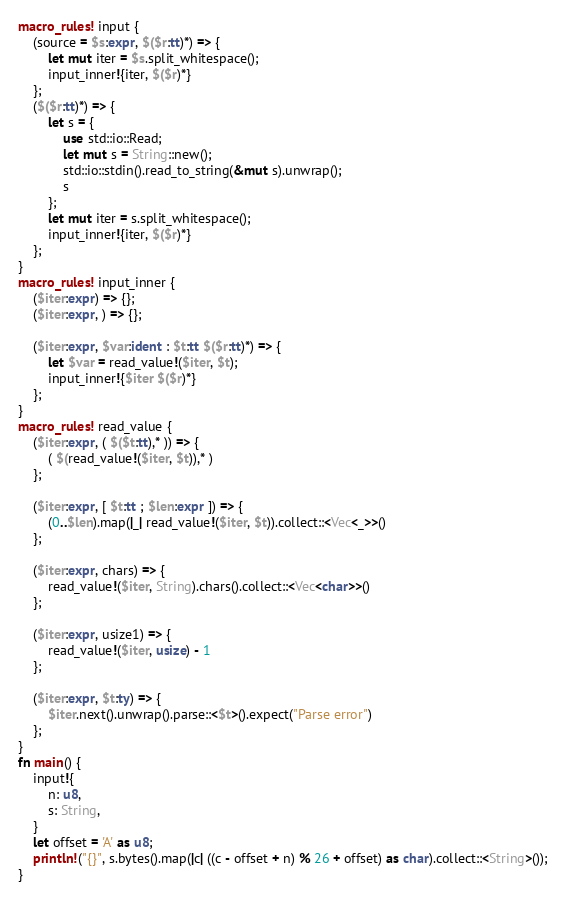Convert code to text. <code><loc_0><loc_0><loc_500><loc_500><_Rust_>macro_rules! input {
    (source = $s:expr, $($r:tt)*) => {
        let mut iter = $s.split_whitespace();
        input_inner!{iter, $($r)*}
    };
    ($($r:tt)*) => {
        let s = {
            use std::io::Read;
            let mut s = String::new();
            std::io::stdin().read_to_string(&mut s).unwrap();
            s
        };
        let mut iter = s.split_whitespace();
        input_inner!{iter, $($r)*}
    };
}
macro_rules! input_inner {
    ($iter:expr) => {};
    ($iter:expr, ) => {};

    ($iter:expr, $var:ident : $t:tt $($r:tt)*) => {
        let $var = read_value!($iter, $t);
        input_inner!{$iter $($r)*}
    };
}
macro_rules! read_value {
    ($iter:expr, ( $($t:tt),* )) => {
        ( $(read_value!($iter, $t)),* )
    };

    ($iter:expr, [ $t:tt ; $len:expr ]) => {
        (0..$len).map(|_| read_value!($iter, $t)).collect::<Vec<_>>()
    };

    ($iter:expr, chars) => {
        read_value!($iter, String).chars().collect::<Vec<char>>()
    };

    ($iter:expr, usize1) => {
        read_value!($iter, usize) - 1
    };

    ($iter:expr, $t:ty) => {
        $iter.next().unwrap().parse::<$t>().expect("Parse error")
    };
}
fn main() {
    input!{
        n: u8,
        s: String,
    }
    let offset = 'A' as u8;
    println!("{}", s.bytes().map(|c| ((c - offset + n) % 26 + offset) as char).collect::<String>());
}
</code> 